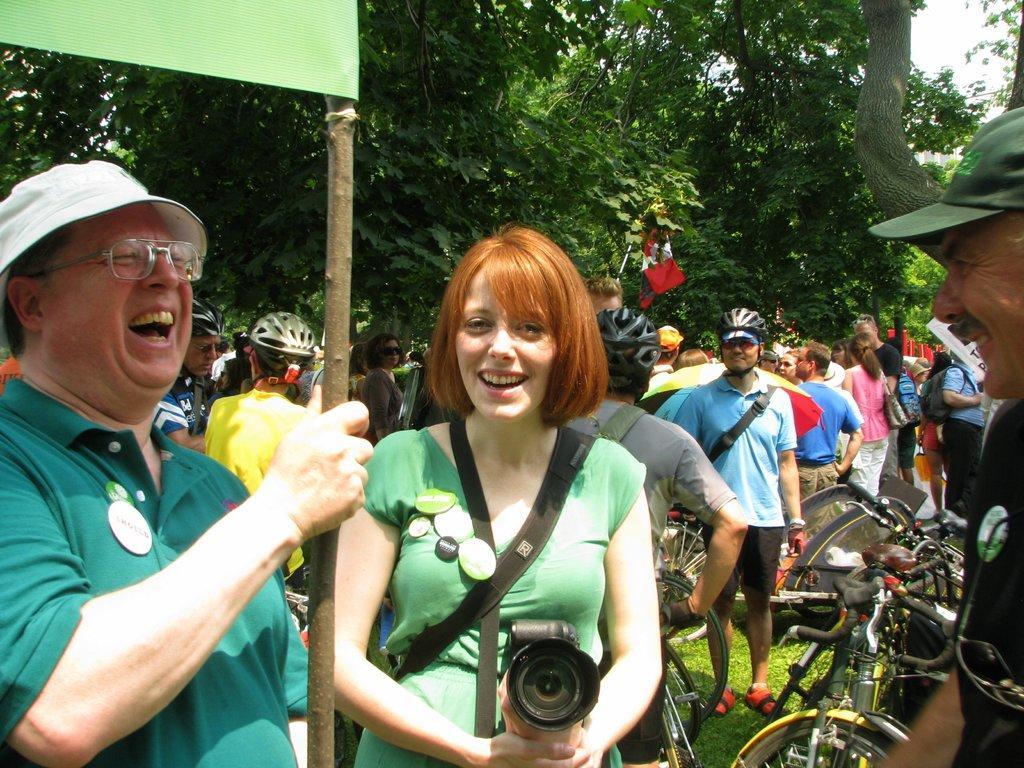Describe this image in one or two sentences. In the left side there is a man standing. He is wearing green color t-shirt on his head there is a cap. He is wearing spectacles. He is laughing. Beside him there is a lady with green color t-shirt holding a camera in her hand. She is smiling. And to the there is another man with black t-shirt. He is wearing cap on his head. Behind him there are many people with bicycles are standing. In the background there are some trees. 